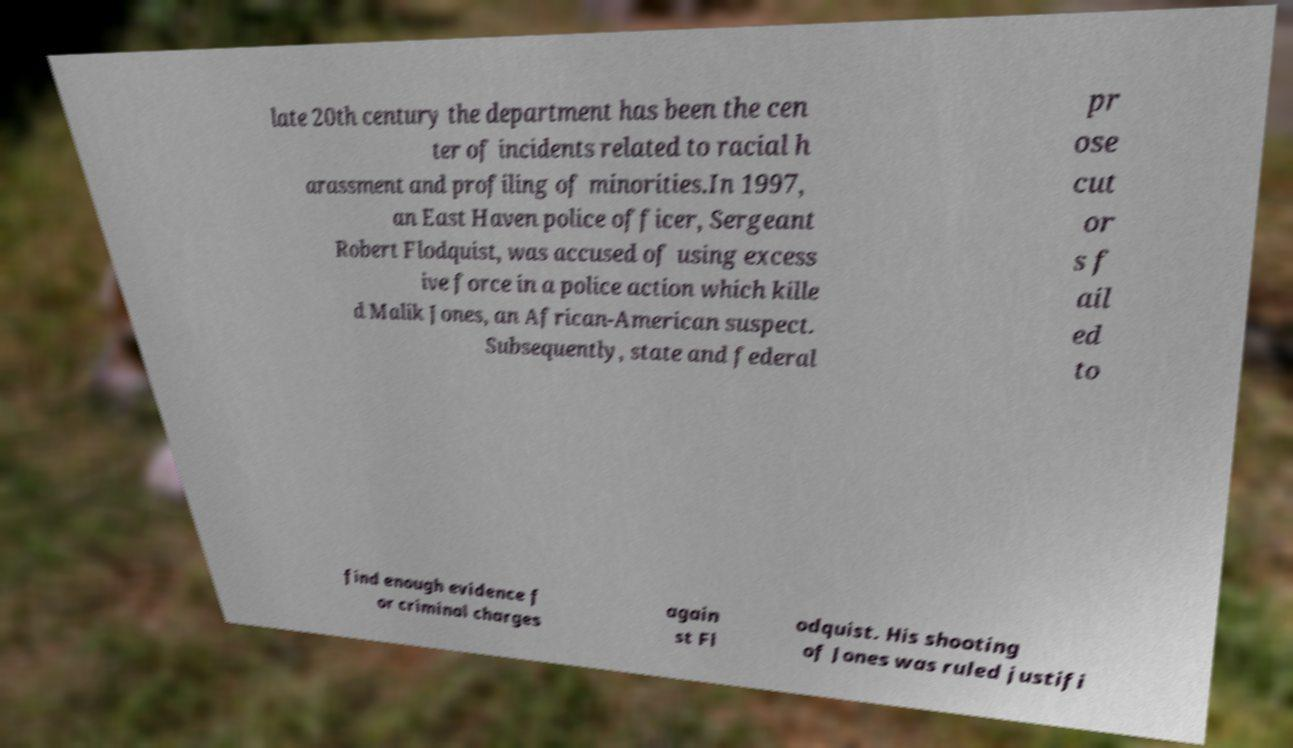Please identify and transcribe the text found in this image. late 20th century the department has been the cen ter of incidents related to racial h arassment and profiling of minorities.In 1997, an East Haven police officer, Sergeant Robert Flodquist, was accused of using excess ive force in a police action which kille d Malik Jones, an African-American suspect. Subsequently, state and federal pr ose cut or s f ail ed to find enough evidence f or criminal charges again st Fl odquist. His shooting of Jones was ruled justifi 